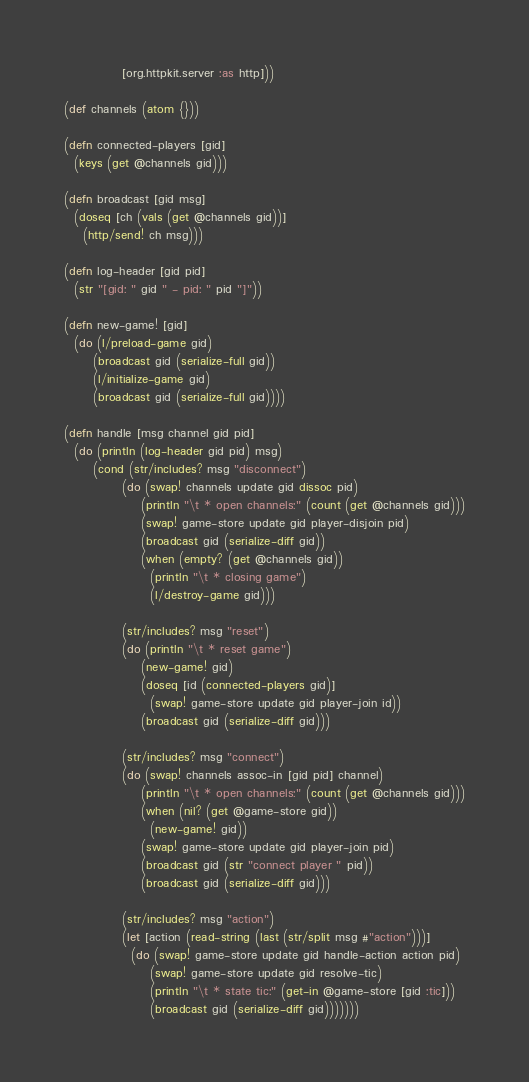Convert code to text. <code><loc_0><loc_0><loc_500><loc_500><_Clojure_>            [org.httpkit.server :as http]))

(def channels (atom {}))

(defn connected-players [gid]
  (keys (get @channels gid)))

(defn broadcast [gid msg]
  (doseq [ch (vals (get @channels gid))]
    (http/send! ch msg)))

(defn log-header [gid pid]
  (str "[gid: " gid " - pid: " pid "]"))

(defn new-game! [gid]
  (do (l/preload-game gid)
      (broadcast gid (serialize-full gid))
      (l/initialize-game gid)
      (broadcast gid (serialize-full gid))))

(defn handle [msg channel gid pid]
  (do (println (log-header gid pid) msg)
      (cond (str/includes? msg "disconnect")
            (do (swap! channels update gid dissoc pid)
                (println "\t * open channels:" (count (get @channels gid)))
                (swap! game-store update gid player-disjoin pid)
                (broadcast gid (serialize-diff gid))
                (when (empty? (get @channels gid))
                  (println "\t * closing game")
                  (l/destroy-game gid)))

            (str/includes? msg "reset")
            (do (println "\t * reset game")
                (new-game! gid)
                (doseq [id (connected-players gid)]
                  (swap! game-store update gid player-join id))
                (broadcast gid (serialize-diff gid)))

            (str/includes? msg "connect")
            (do (swap! channels assoc-in [gid pid] channel)
                (println "\t * open channels:" (count (get @channels gid)))
                (when (nil? (get @game-store gid))
                  (new-game! gid))
                (swap! game-store update gid player-join pid)
                (broadcast gid (str "connect player " pid))
                (broadcast gid (serialize-diff gid)))

            (str/includes? msg "action")
            (let [action (read-string (last (str/split msg #"action")))]
              (do (swap! game-store update gid handle-action action pid)
                  (swap! game-store update gid resolve-tic)
                  (println "\t * state tic:" (get-in @game-store [gid :tic]))
                  (broadcast gid (serialize-diff gid)))))))</code> 